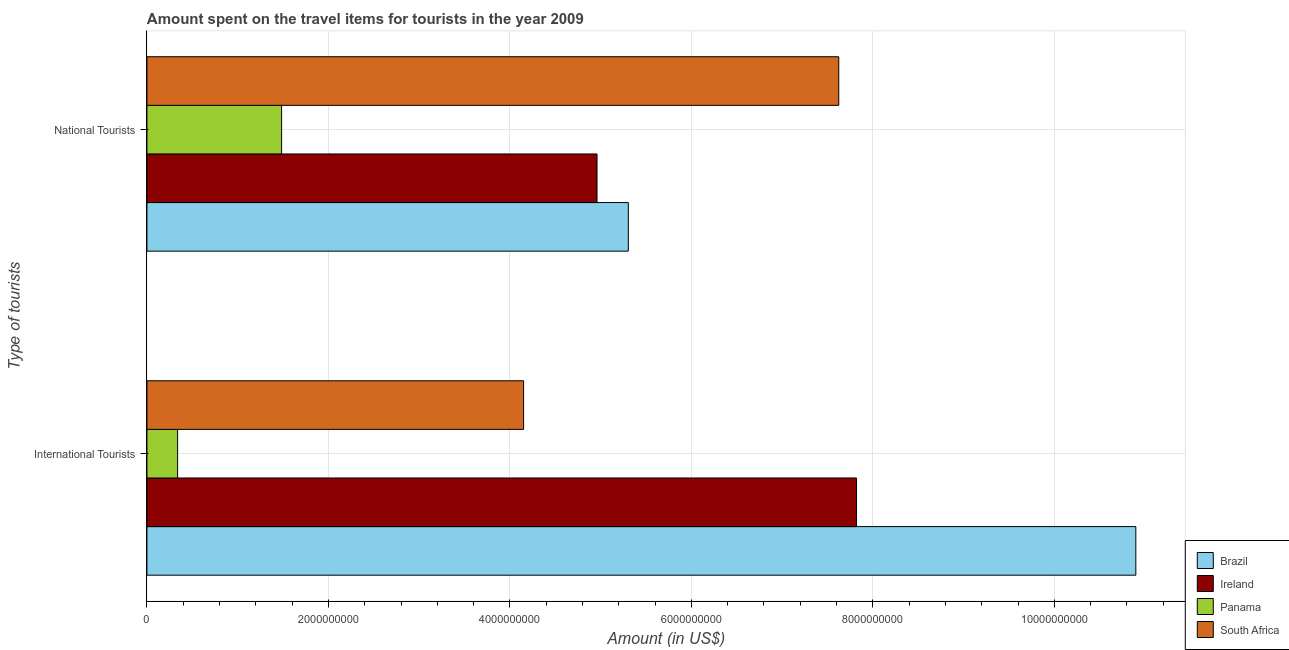How many groups of bars are there?
Your answer should be very brief. 2. How many bars are there on the 1st tick from the top?
Give a very brief answer. 4. What is the label of the 1st group of bars from the top?
Provide a short and direct response. National Tourists. What is the amount spent on travel items of national tourists in Brazil?
Your response must be concise. 5.30e+09. Across all countries, what is the maximum amount spent on travel items of national tourists?
Provide a short and direct response. 7.62e+09. Across all countries, what is the minimum amount spent on travel items of national tourists?
Ensure brevity in your answer.  1.48e+09. In which country was the amount spent on travel items of national tourists maximum?
Offer a terse response. South Africa. In which country was the amount spent on travel items of national tourists minimum?
Provide a succinct answer. Panama. What is the total amount spent on travel items of international tourists in the graph?
Provide a succinct answer. 2.32e+1. What is the difference between the amount spent on travel items of national tourists in South Africa and that in Ireland?
Give a very brief answer. 2.66e+09. What is the difference between the amount spent on travel items of national tourists in South Africa and the amount spent on travel items of international tourists in Brazil?
Keep it short and to the point. -3.27e+09. What is the average amount spent on travel items of international tourists per country?
Your answer should be compact. 5.80e+09. What is the difference between the amount spent on travel items of international tourists and amount spent on travel items of national tourists in Ireland?
Give a very brief answer. 2.86e+09. What is the ratio of the amount spent on travel items of international tourists in Ireland to that in Brazil?
Your response must be concise. 0.72. Is the amount spent on travel items of international tourists in Brazil less than that in Panama?
Provide a succinct answer. No. What does the 1st bar from the top in International Tourists represents?
Your response must be concise. South Africa. What does the 3rd bar from the bottom in National Tourists represents?
Make the answer very short. Panama. Are all the bars in the graph horizontal?
Your answer should be very brief. Yes. How many countries are there in the graph?
Your answer should be very brief. 4. What is the difference between two consecutive major ticks on the X-axis?
Keep it short and to the point. 2.00e+09. Are the values on the major ticks of X-axis written in scientific E-notation?
Your answer should be compact. No. Does the graph contain grids?
Give a very brief answer. Yes. How are the legend labels stacked?
Give a very brief answer. Vertical. What is the title of the graph?
Your answer should be very brief. Amount spent on the travel items for tourists in the year 2009. Does "Kiribati" appear as one of the legend labels in the graph?
Provide a short and direct response. No. What is the label or title of the X-axis?
Give a very brief answer. Amount (in US$). What is the label or title of the Y-axis?
Provide a short and direct response. Type of tourists. What is the Amount (in US$) in Brazil in International Tourists?
Ensure brevity in your answer.  1.09e+1. What is the Amount (in US$) of Ireland in International Tourists?
Provide a succinct answer. 7.82e+09. What is the Amount (in US$) in Panama in International Tourists?
Make the answer very short. 3.38e+08. What is the Amount (in US$) in South Africa in International Tourists?
Offer a terse response. 4.15e+09. What is the Amount (in US$) of Brazil in National Tourists?
Provide a succinct answer. 5.30e+09. What is the Amount (in US$) in Ireland in National Tourists?
Keep it short and to the point. 4.96e+09. What is the Amount (in US$) in Panama in National Tourists?
Your answer should be very brief. 1.48e+09. What is the Amount (in US$) in South Africa in National Tourists?
Offer a very short reply. 7.62e+09. Across all Type of tourists, what is the maximum Amount (in US$) of Brazil?
Ensure brevity in your answer.  1.09e+1. Across all Type of tourists, what is the maximum Amount (in US$) in Ireland?
Your answer should be very brief. 7.82e+09. Across all Type of tourists, what is the maximum Amount (in US$) in Panama?
Give a very brief answer. 1.48e+09. Across all Type of tourists, what is the maximum Amount (in US$) in South Africa?
Your answer should be very brief. 7.62e+09. Across all Type of tourists, what is the minimum Amount (in US$) in Brazil?
Provide a short and direct response. 5.30e+09. Across all Type of tourists, what is the minimum Amount (in US$) in Ireland?
Keep it short and to the point. 4.96e+09. Across all Type of tourists, what is the minimum Amount (in US$) of Panama?
Your response must be concise. 3.38e+08. Across all Type of tourists, what is the minimum Amount (in US$) in South Africa?
Offer a very short reply. 4.15e+09. What is the total Amount (in US$) of Brazil in the graph?
Give a very brief answer. 1.62e+1. What is the total Amount (in US$) in Ireland in the graph?
Ensure brevity in your answer.  1.28e+1. What is the total Amount (in US$) of Panama in the graph?
Make the answer very short. 1.82e+09. What is the total Amount (in US$) in South Africa in the graph?
Keep it short and to the point. 1.18e+1. What is the difference between the Amount (in US$) of Brazil in International Tourists and that in National Tourists?
Provide a short and direct response. 5.59e+09. What is the difference between the Amount (in US$) of Ireland in International Tourists and that in National Tourists?
Provide a short and direct response. 2.86e+09. What is the difference between the Amount (in US$) of Panama in International Tourists and that in National Tourists?
Offer a very short reply. -1.15e+09. What is the difference between the Amount (in US$) of South Africa in International Tourists and that in National Tourists?
Keep it short and to the point. -3.47e+09. What is the difference between the Amount (in US$) in Brazil in International Tourists and the Amount (in US$) in Ireland in National Tourists?
Provide a short and direct response. 5.94e+09. What is the difference between the Amount (in US$) of Brazil in International Tourists and the Amount (in US$) of Panama in National Tourists?
Your answer should be very brief. 9.41e+09. What is the difference between the Amount (in US$) of Brazil in International Tourists and the Amount (in US$) of South Africa in National Tourists?
Offer a very short reply. 3.27e+09. What is the difference between the Amount (in US$) of Ireland in International Tourists and the Amount (in US$) of Panama in National Tourists?
Offer a very short reply. 6.34e+09. What is the difference between the Amount (in US$) in Ireland in International Tourists and the Amount (in US$) in South Africa in National Tourists?
Make the answer very short. 1.96e+08. What is the difference between the Amount (in US$) in Panama in International Tourists and the Amount (in US$) in South Africa in National Tourists?
Provide a succinct answer. -7.29e+09. What is the average Amount (in US$) in Brazil per Type of tourists?
Your answer should be very brief. 8.10e+09. What is the average Amount (in US$) of Ireland per Type of tourists?
Make the answer very short. 6.39e+09. What is the average Amount (in US$) in Panama per Type of tourists?
Ensure brevity in your answer.  9.11e+08. What is the average Amount (in US$) in South Africa per Type of tourists?
Offer a very short reply. 5.89e+09. What is the difference between the Amount (in US$) of Brazil and Amount (in US$) of Ireland in International Tourists?
Your response must be concise. 3.08e+09. What is the difference between the Amount (in US$) of Brazil and Amount (in US$) of Panama in International Tourists?
Offer a very short reply. 1.06e+1. What is the difference between the Amount (in US$) of Brazil and Amount (in US$) of South Africa in International Tourists?
Your answer should be compact. 6.75e+09. What is the difference between the Amount (in US$) in Ireland and Amount (in US$) in Panama in International Tourists?
Offer a terse response. 7.48e+09. What is the difference between the Amount (in US$) in Ireland and Amount (in US$) in South Africa in International Tourists?
Make the answer very short. 3.67e+09. What is the difference between the Amount (in US$) of Panama and Amount (in US$) of South Africa in International Tourists?
Ensure brevity in your answer.  -3.81e+09. What is the difference between the Amount (in US$) in Brazil and Amount (in US$) in Ireland in National Tourists?
Your answer should be compact. 3.45e+08. What is the difference between the Amount (in US$) in Brazil and Amount (in US$) in Panama in National Tourists?
Ensure brevity in your answer.  3.82e+09. What is the difference between the Amount (in US$) of Brazil and Amount (in US$) of South Africa in National Tourists?
Offer a very short reply. -2.32e+09. What is the difference between the Amount (in US$) in Ireland and Amount (in US$) in Panama in National Tourists?
Offer a very short reply. 3.48e+09. What is the difference between the Amount (in US$) in Ireland and Amount (in US$) in South Africa in National Tourists?
Offer a very short reply. -2.66e+09. What is the difference between the Amount (in US$) of Panama and Amount (in US$) of South Africa in National Tourists?
Ensure brevity in your answer.  -6.14e+09. What is the ratio of the Amount (in US$) of Brazil in International Tourists to that in National Tourists?
Offer a very short reply. 2.05. What is the ratio of the Amount (in US$) in Ireland in International Tourists to that in National Tourists?
Provide a short and direct response. 1.58. What is the ratio of the Amount (in US$) in Panama in International Tourists to that in National Tourists?
Provide a short and direct response. 0.23. What is the ratio of the Amount (in US$) of South Africa in International Tourists to that in National Tourists?
Offer a very short reply. 0.54. What is the difference between the highest and the second highest Amount (in US$) of Brazil?
Offer a very short reply. 5.59e+09. What is the difference between the highest and the second highest Amount (in US$) in Ireland?
Your answer should be very brief. 2.86e+09. What is the difference between the highest and the second highest Amount (in US$) in Panama?
Your answer should be compact. 1.15e+09. What is the difference between the highest and the second highest Amount (in US$) in South Africa?
Offer a terse response. 3.47e+09. What is the difference between the highest and the lowest Amount (in US$) of Brazil?
Your answer should be very brief. 5.59e+09. What is the difference between the highest and the lowest Amount (in US$) of Ireland?
Offer a terse response. 2.86e+09. What is the difference between the highest and the lowest Amount (in US$) of Panama?
Your response must be concise. 1.15e+09. What is the difference between the highest and the lowest Amount (in US$) in South Africa?
Keep it short and to the point. 3.47e+09. 